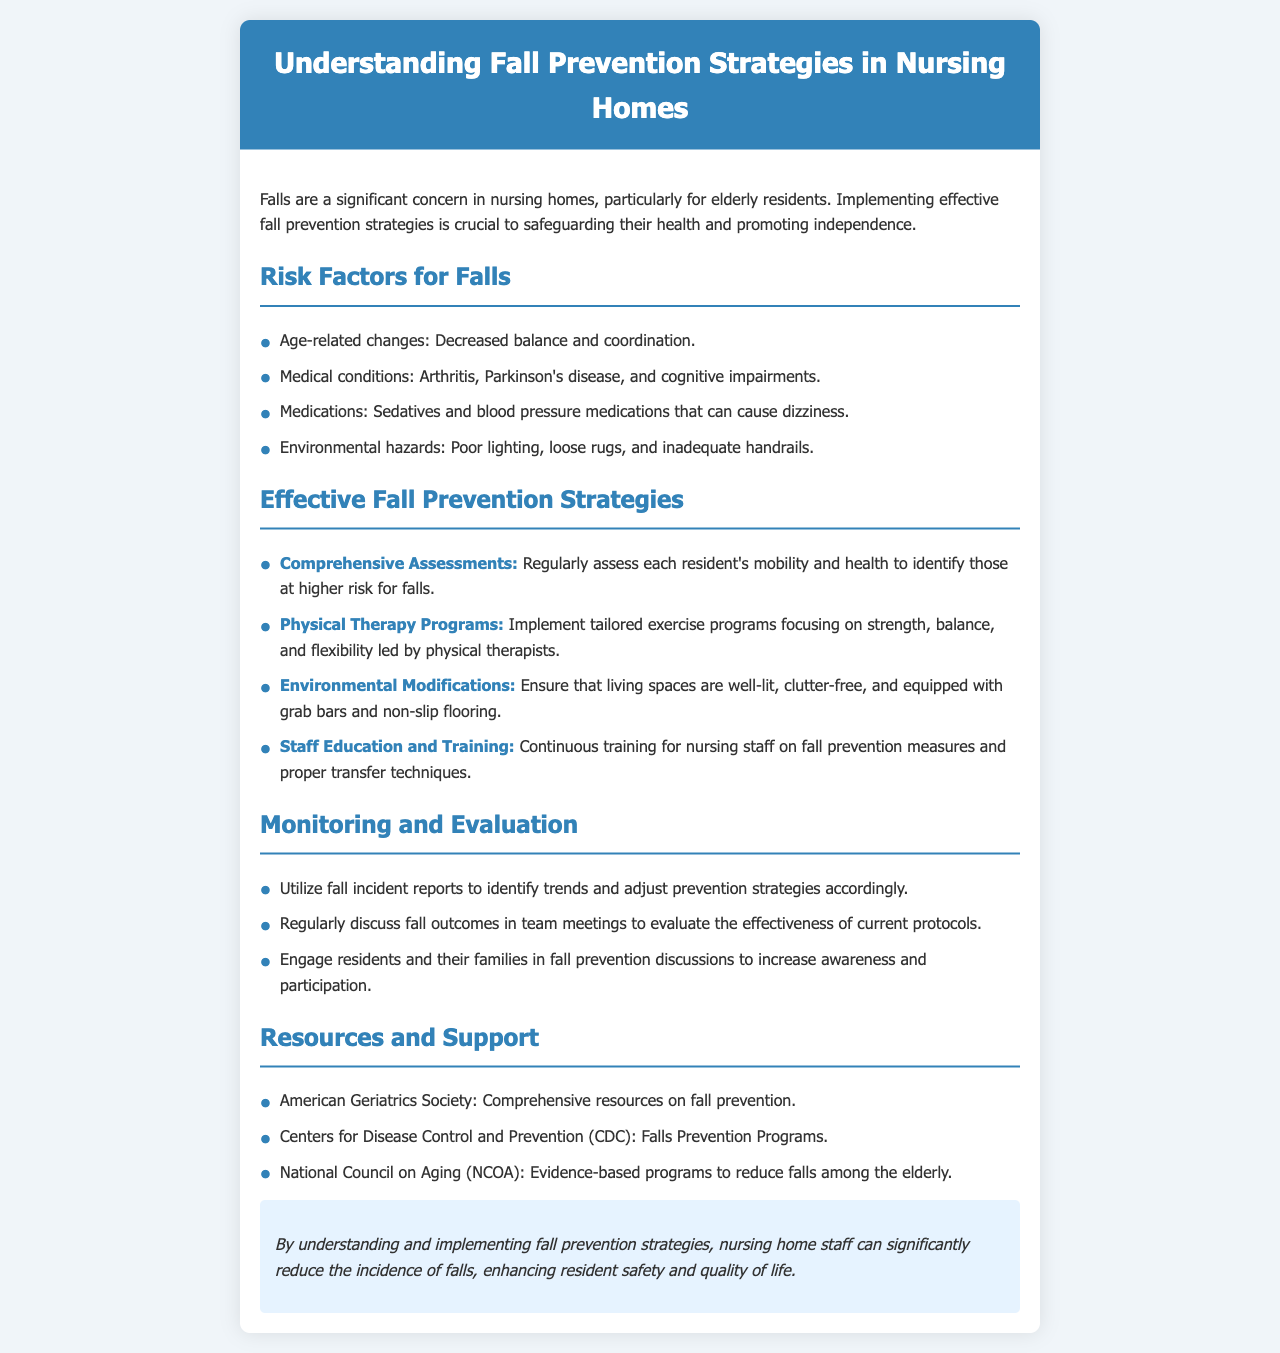What are the age-related changes that contribute to falls? The document lists "Decreased balance and coordination" as an age-related change that contributes to falls.
Answer: Decreased balance and coordination What is one medical condition that increases fall risk? The document mentions "Arthritis" as a medical condition that increases fall risk.
Answer: Arthritis Which organization provides comprehensive resources on fall prevention? The document states that the "American Geriatrics Society" provides comprehensive resources on fall prevention.
Answer: American Geriatrics Society What strategy involves regular mobility assessments? The document specifies "Comprehensive Assessments" as the strategy that involves regular mobility assessments.
Answer: Comprehensive Assessments What type of training is emphasized for nursing staff? The document highlights "Continuous training" for nursing staff as essential for fall prevention measures.
Answer: Continuous training How should living spaces be modified to prevent falls? The document suggests ensuring spaces are "well-lit, clutter-free, and equipped with grab bars" to prevent falls.
Answer: Well-lit, clutter-free, and equipped with grab bars In what context should fall outcomes be discussed? The document states that fall outcomes should be discussed in "team meetings" to evaluate the effectiveness of current protocols.
Answer: Team meetings What is the ultimate goal of implementing fall prevention strategies? The document concludes that the ultimate goal is to "enhance resident safety and quality of life."
Answer: Enhance resident safety and quality of life 